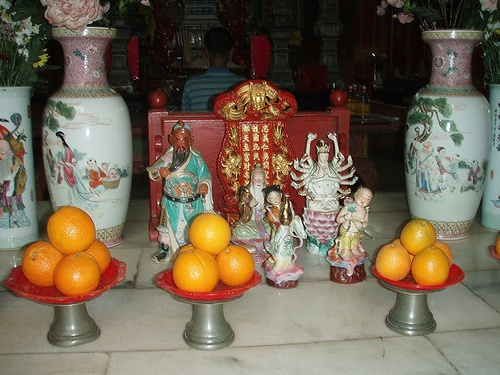Describe the objects in this image and their specific colors. I can see potted plant in gray, darkgray, and lightgray tones, potted plant in gray, darkgray, black, and lightgray tones, vase in gray, darkgray, and lightgray tones, vase in gray, darkgray, lightgray, and black tones, and potted plant in gray, black, and darkgray tones in this image. 